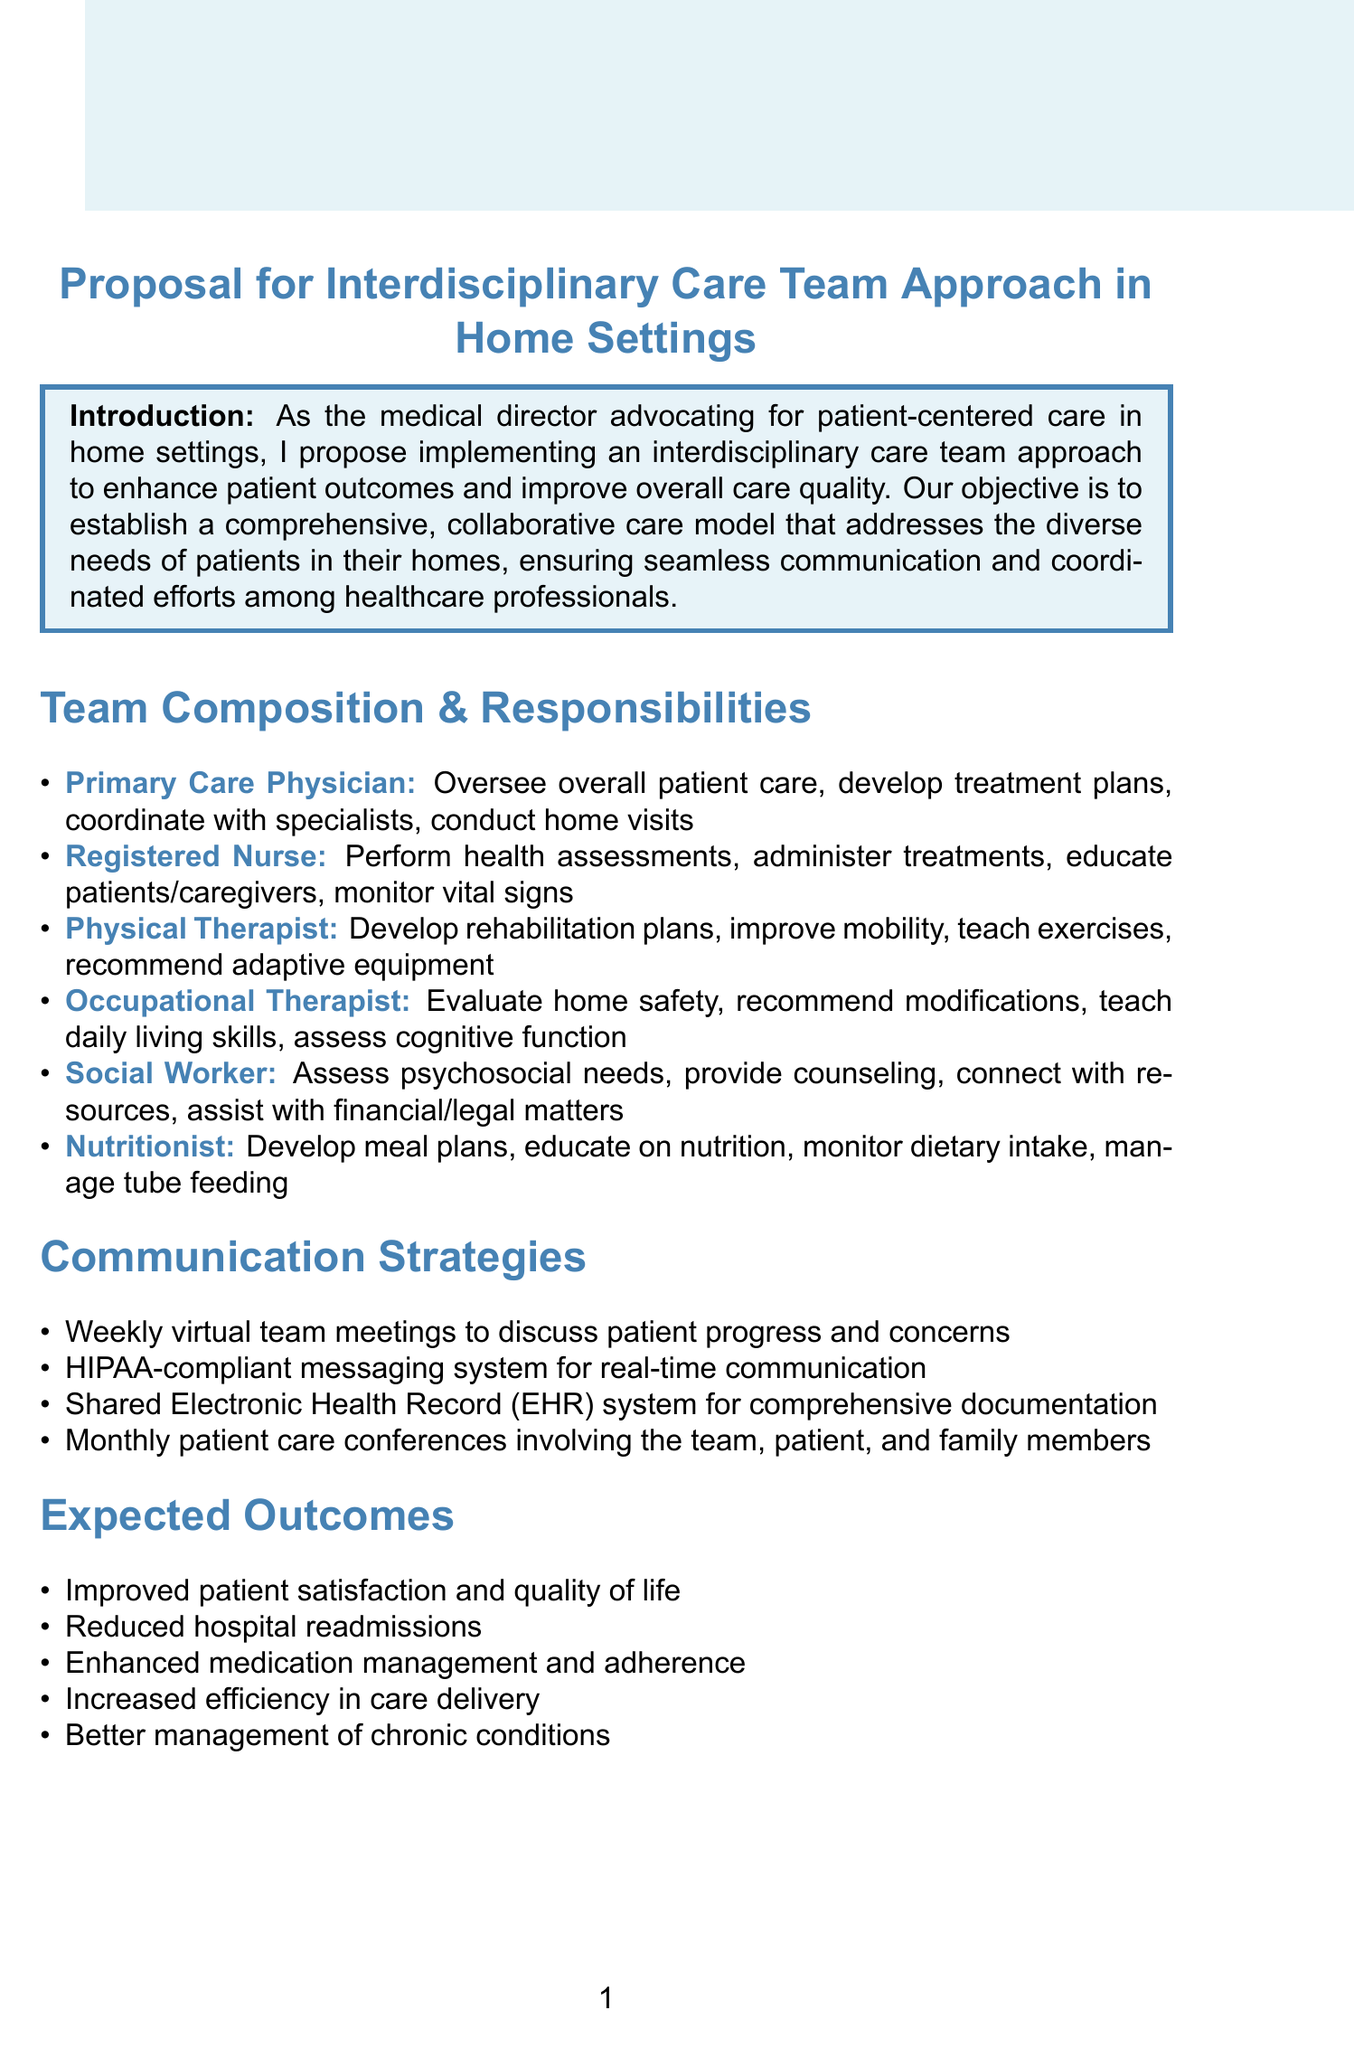What is the title of the memo? The title of the memo is found in the header of the document.
Answer: Proposal for Interdisciplinary Care Team Approach in Home Settings What is the role of the Registered Nurse? The responsibilities of the Registered Nurse are listed under the team composition section.
Answer: Perform routine health assessments How long is the second phase of implementation? The duration of the second phase is detailed in the implementation timeline.
Answer: 3-4 months What is one expected outcome of the interdisciplinary care team approach? Expected outcomes are outlined in a specific section of the document.
Answer: Improved patient satisfaction and quality of life What is the method used for secure communication among team members? The document specifies communication strategies including methods used for secure communication.
Answer: Secure Messaging Platform How many roles are listed in the team composition? The number of roles can be counted from the list of team members in the document.
Answer: Six What is the objective of the proposal? The objective is clearly stated in the introduction section of the memo.
Answer: To establish a comprehensive, collaborative care model What is the purpose of the Patient Care Conferences? The purpose of Patient Care Conferences is explained in the communication strategies section.
Answer: To review goals and progress 